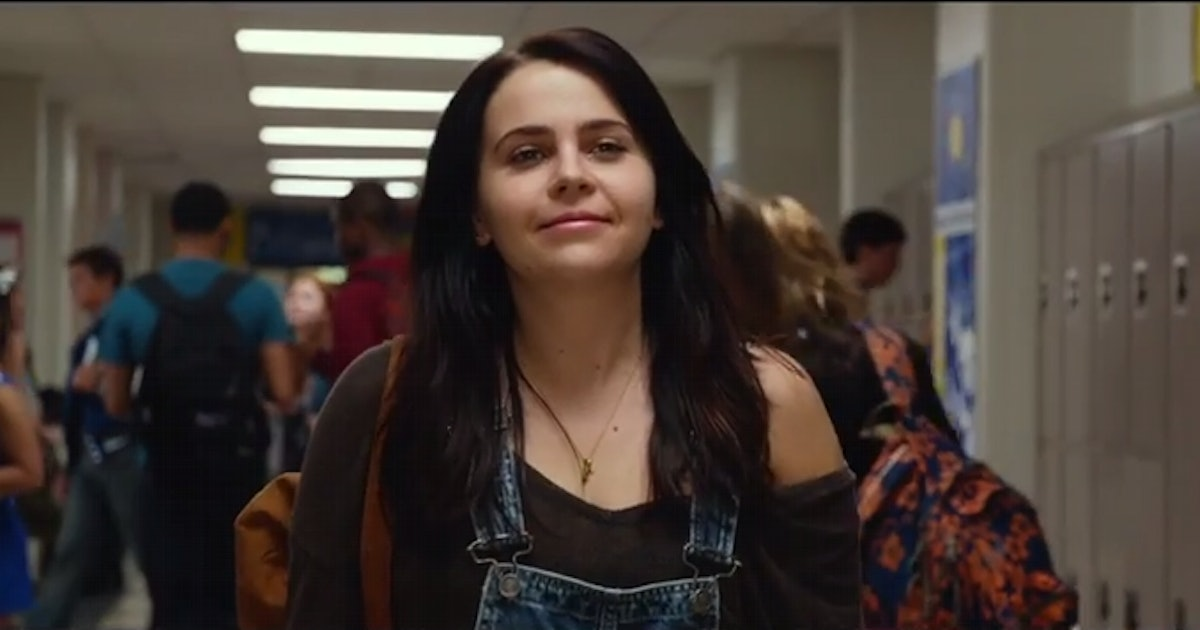From this image, describe a realistic scenario that might follow. After this moment, the character, let's call her Mia, heads to her next class, where she has an important test. She's feeling a bit nervous but hopeful, as she's prepared diligently. The hallway noise fades as she enters the classroom, greeted by the whispers of students shuffling in their seats and the faint smell of chalk. Taking her seat, Mia takes a deep breath and starts reviewing her notes one last time, determined to excel. 